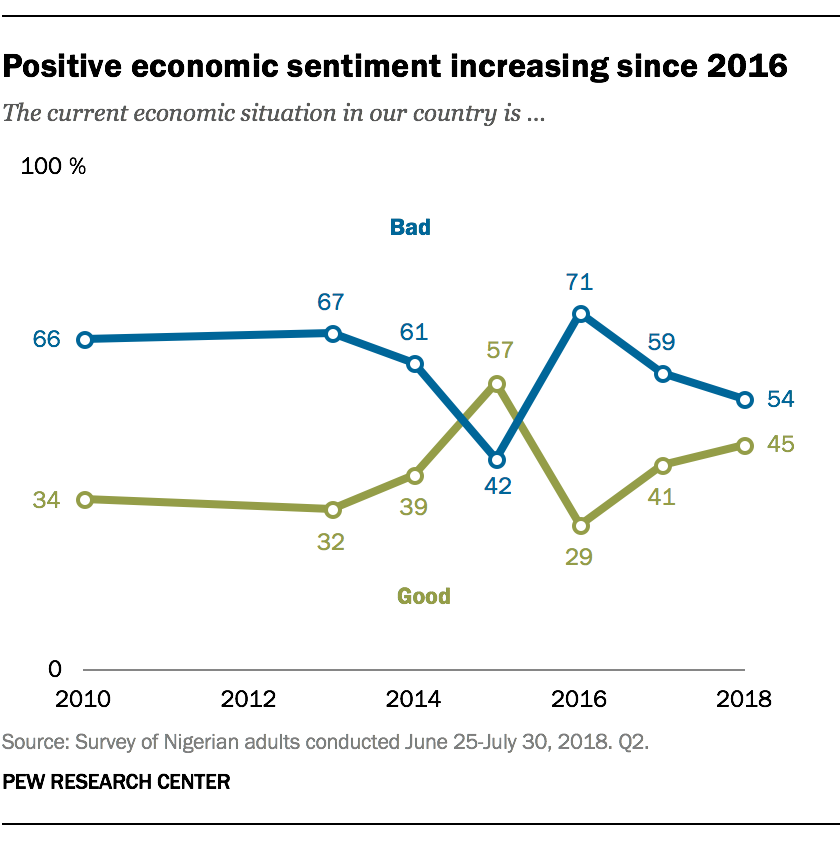Identify some key points in this picture. In 2018, there is a difference between the blue and green data points. Specifically, the blue data point is lower than the green data point by 9.. I'm sorry, but I'm not sure what you are asking. Could you please provide more context or clarify your question? 